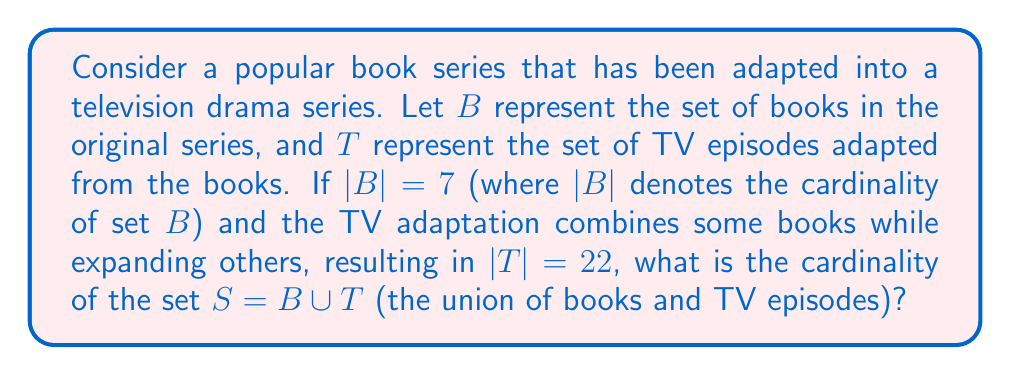Can you solve this math problem? To solve this problem, we need to understand the concept of set union and how it relates to cardinality. Let's approach this step-by-step:

1. We are given two sets:
   $B$ (books): $|B| = 7$
   $T$ (TV episodes): $|T| = 22$

2. We need to find $|S|$ where $S = B \cup T$

3. The cardinality of a union of two sets is given by the formula:
   $|A \cup B| = |A| + |B| - |A \cap B|$

4. In our case, this translates to:
   $|S| = |B \cup T| = |B| + |T| - |B \cap T|$

5. We know $|B|$ and $|T|$, but we need to consider $|B \cap T|$. Since each TV episode is based on content from the books, we can consider that the intersection of $B$ and $T$ is essentially $B$ itself.

6. Therefore, $|B \cap T| = |B| = 7$

7. Now we can substitute all values into our formula:
   $|S| = |B| + |T| - |B \cap T|$
   $|S| = 7 + 22 - 7$
   $|S| = 22$

8. This result makes sense because every TV episode is based on the books, so the union doesn't add any new elements beyond what's already in the set of TV episodes.
Answer: $|S| = 22$ 